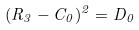<formula> <loc_0><loc_0><loc_500><loc_500>( R _ { 3 } - C _ { 0 } ) ^ { 2 } = D _ { 0 }</formula> 